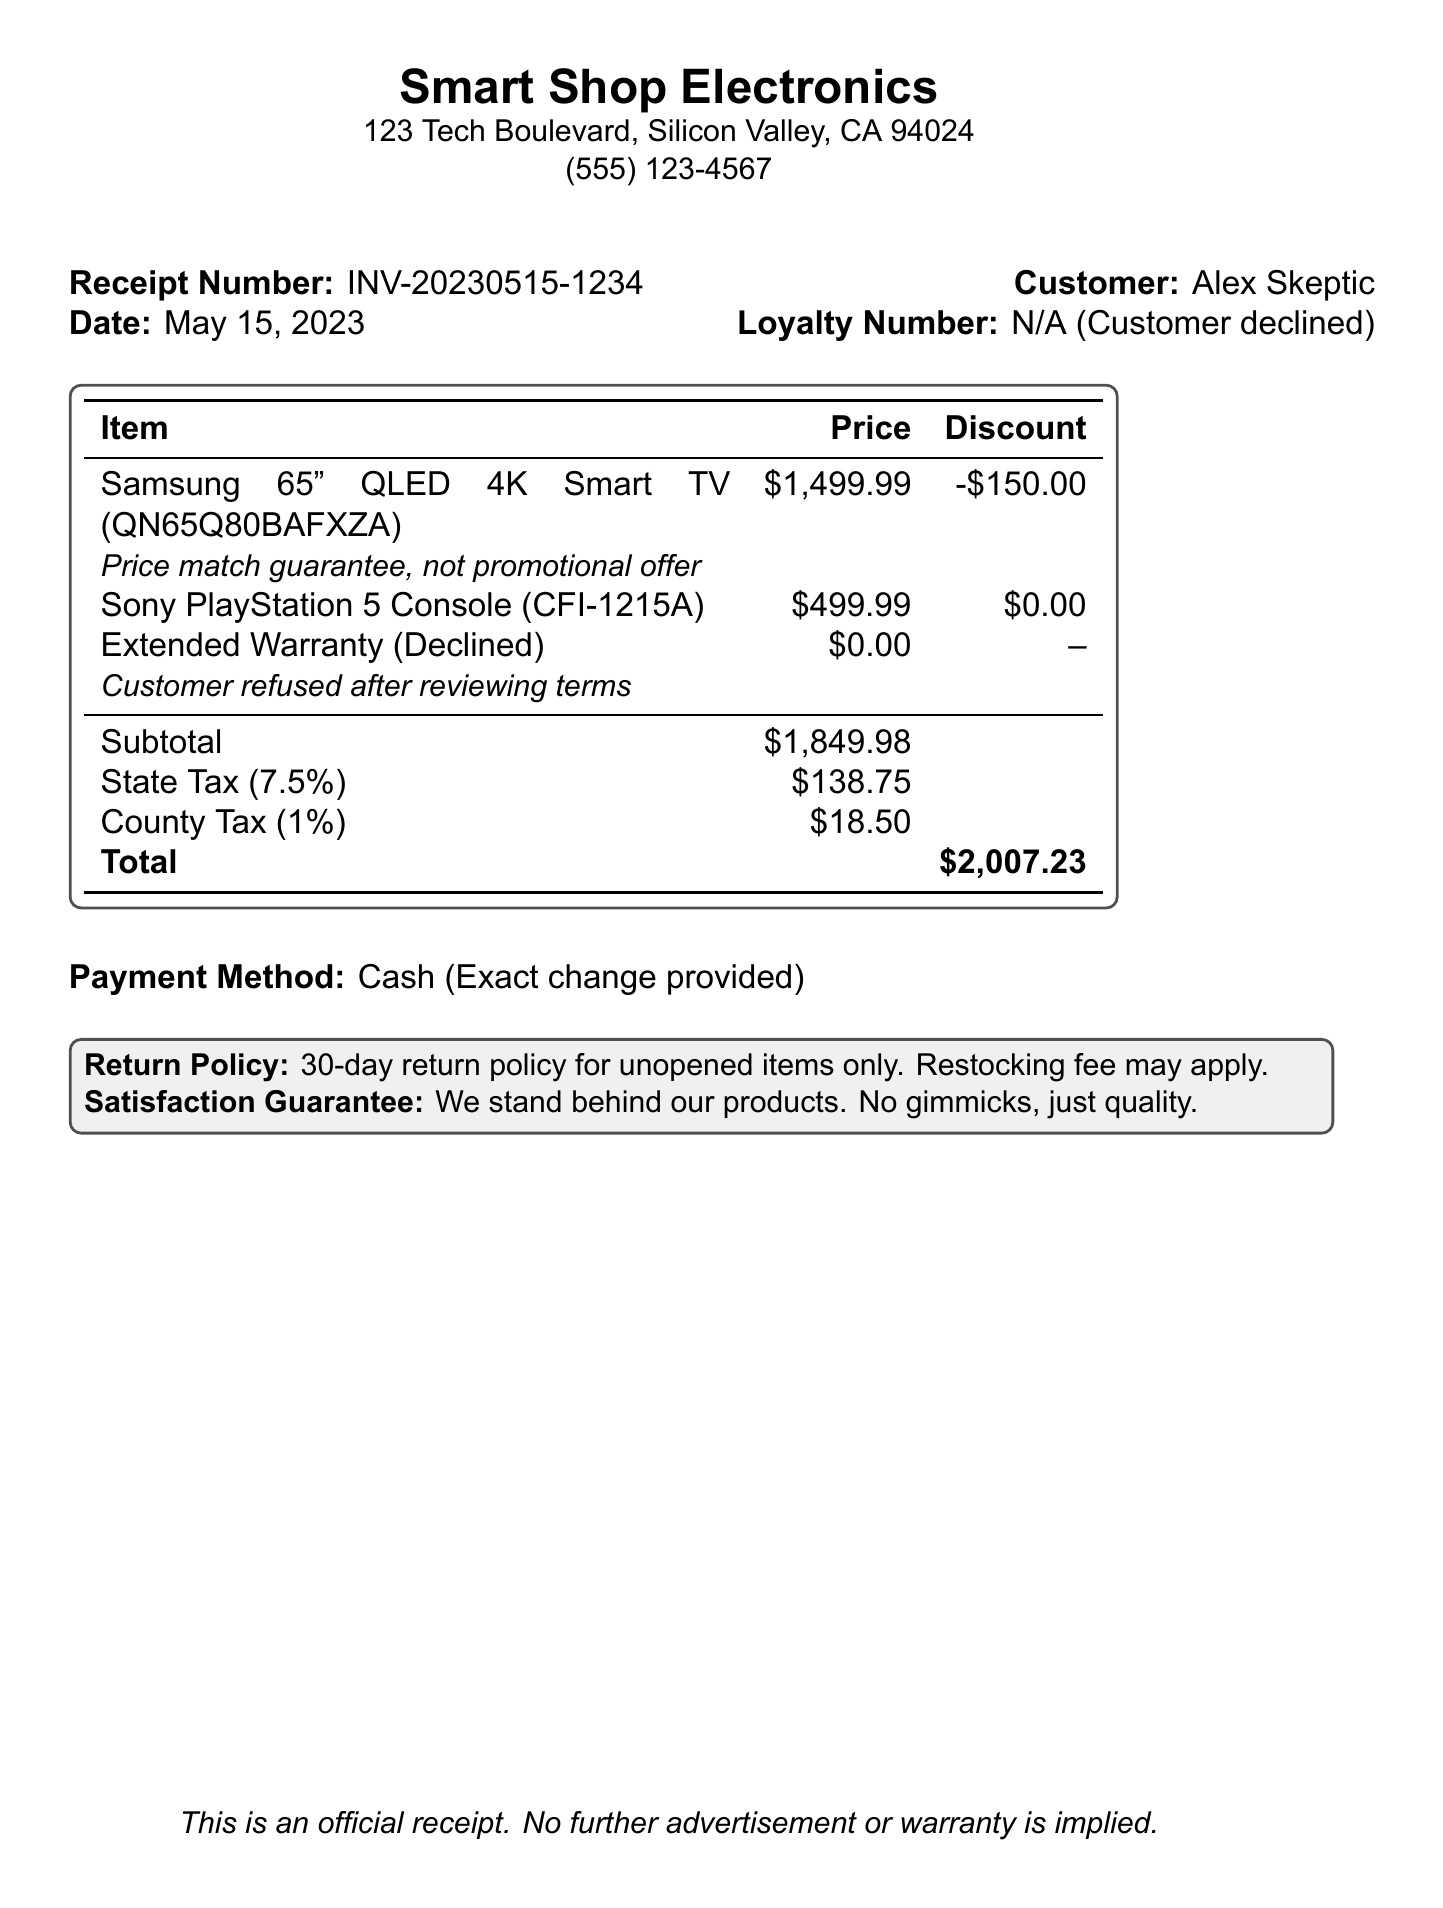What is the receipt number? The receipt number is clearly stated near the top of the document under "Receipt Number."
Answer: INV-20230515-1234 What is the date of the purchase? The purchase date is mentioned alongside the receipt number, indicating when the transaction occurred.
Answer: May 15, 2023 What was the subtotal before taxes? The subtotal is calculated before adding taxes and is listed in the itemized breakdown.
Answer: $1,849.98 What is the amount of the discount applied to the Samsung TV? The discount for the Samsung TV is specified under the discount column for that item.
Answer: -$150.00 What is the percentage of state tax applied? The percentage of state tax is mentioned in the table as part of the tax calculations.
Answer: 7.5% What was the payment method used? The payment method is noted toward the end of the document, indicating how the customer paid.
Answer: Cash How long is the return policy? The return policy duration is explicitly stated within the document’s policy section.
Answer: 30-day Was an extended warranty purchased? The purchase status of the extended warranty is mentioned after the item's details, showing whether it was accepted or declined.
Answer: Declined What is the total amount after taxes? The total amount after including taxes is the last entry in the itemized bill, summarizing the final cost.
Answer: $2,007.23 What does the satisfaction guarantee state? The document includes a brief statement regarding the satisfaction guarantee regarding product quality.
Answer: No gimmicks, just quality 